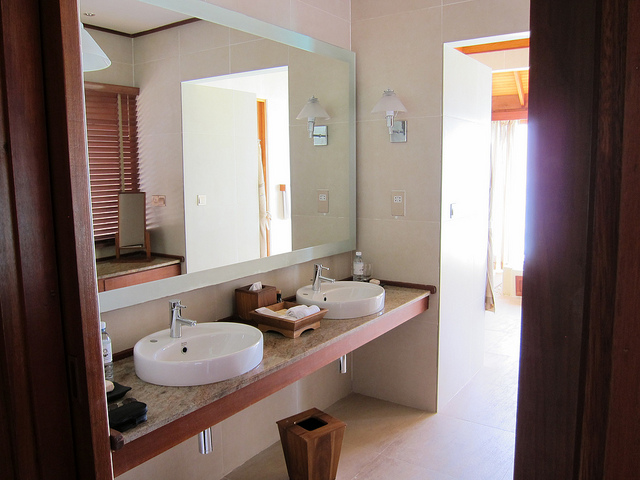How many sinks are there in the image? There are two sinks present in the image. Both are oval and mounted on a wide, stone countertop that stretches across a large portion of the room, suggesting a design that values both aesthetics and functionality. 